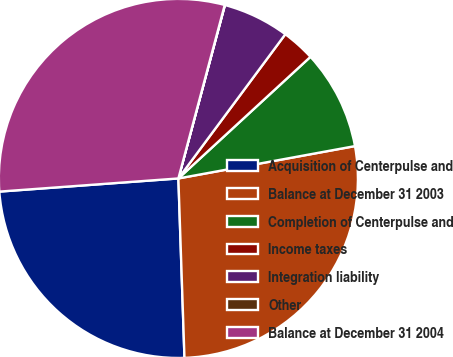Convert chart to OTSL. <chart><loc_0><loc_0><loc_500><loc_500><pie_chart><fcel>Acquisition of Centerpulse and<fcel>Balance at December 31 2003<fcel>Completion of Centerpulse and<fcel>Income taxes<fcel>Integration liability<fcel>Other<fcel>Balance at December 31 2004<nl><fcel>24.37%<fcel>27.34%<fcel>8.96%<fcel>3.0%<fcel>5.98%<fcel>0.02%<fcel>30.32%<nl></chart> 